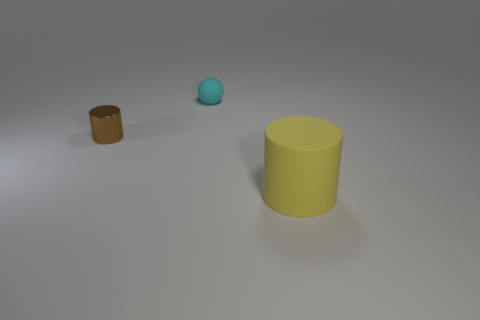Add 3 big yellow cylinders. How many objects exist? 6 Subtract all brown cylinders. How many cylinders are left? 1 Add 2 shiny things. How many shiny things are left? 3 Add 1 small cyan matte balls. How many small cyan matte balls exist? 2 Subtract 0 purple cubes. How many objects are left? 3 Subtract all spheres. How many objects are left? 2 Subtract 1 balls. How many balls are left? 0 Subtract all blue spheres. Subtract all gray cylinders. How many spheres are left? 1 Subtract all brown cubes. How many purple spheres are left? 0 Subtract all matte objects. Subtract all cyan objects. How many objects are left? 0 